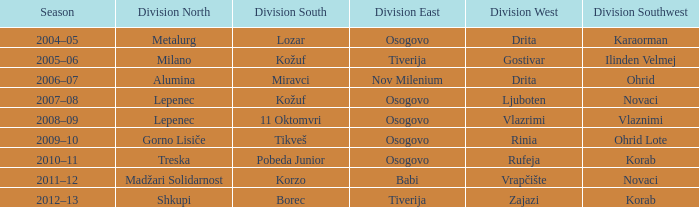Who won Division Southwest when Madžari Solidarnost won Division North? Novaci. 